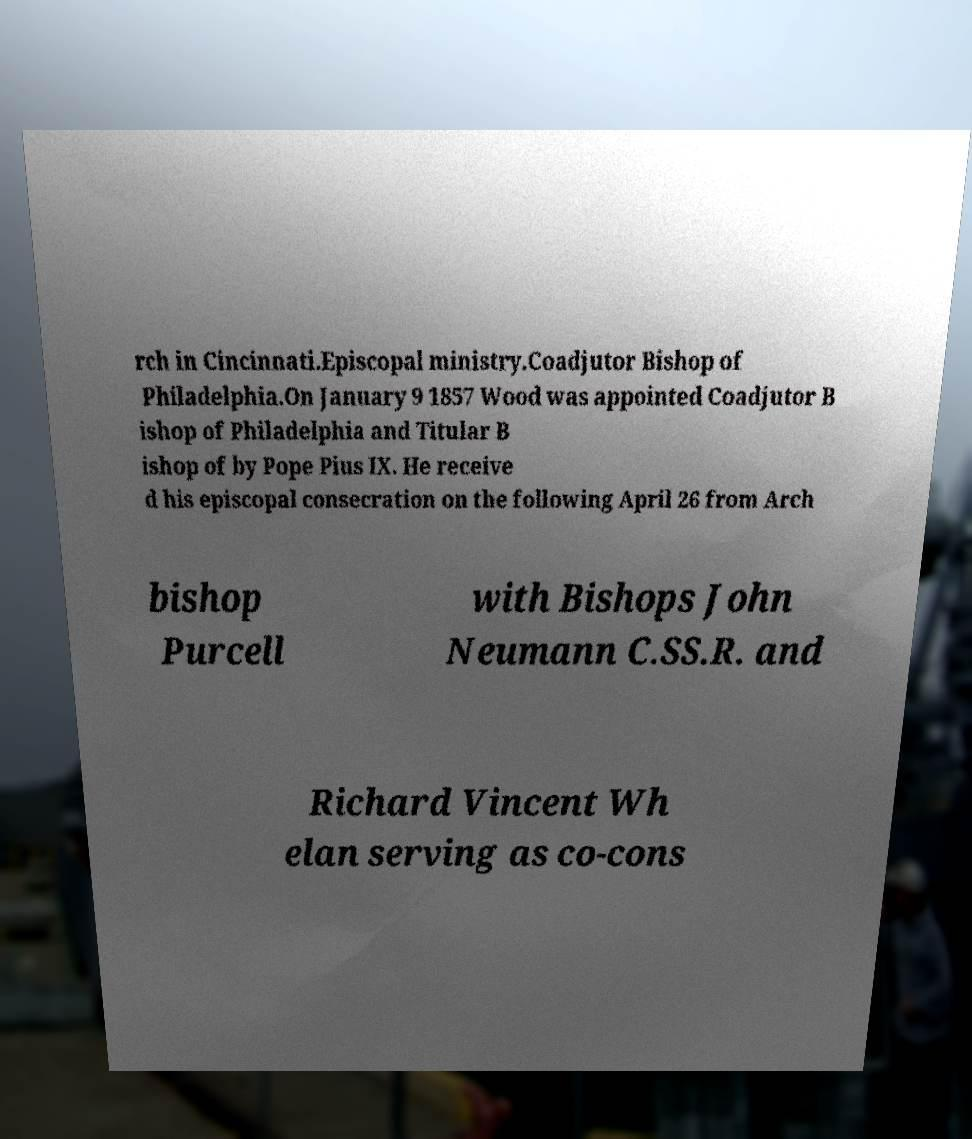There's text embedded in this image that I need extracted. Can you transcribe it verbatim? rch in Cincinnati.Episcopal ministry.Coadjutor Bishop of Philadelphia.On January 9 1857 Wood was appointed Coadjutor B ishop of Philadelphia and Titular B ishop of by Pope Pius IX. He receive d his episcopal consecration on the following April 26 from Arch bishop Purcell with Bishops John Neumann C.SS.R. and Richard Vincent Wh elan serving as co-cons 